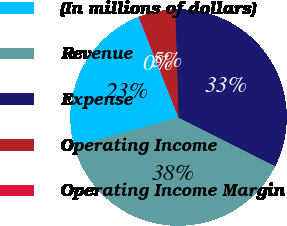Convert chart. <chart><loc_0><loc_0><loc_500><loc_500><pie_chart><fcel>(In millions of dollars)<fcel>Revenue<fcel>Expense<fcel>Operating Income<fcel>Operating Income Margin<nl><fcel>23.3%<fcel>38.27%<fcel>32.91%<fcel>5.36%<fcel>0.16%<nl></chart> 